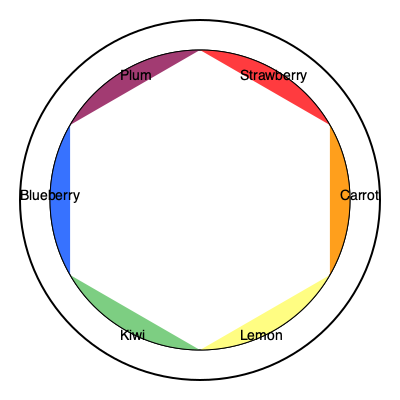Using the food-inspired color wheel provided, which two colors would create a complementary color scheme for a vibrant fabric design? To determine a complementary color scheme using the food-inspired color wheel, follow these steps:

1. Understand complementary colors: Complementary colors are pairs of colors that are opposite each other on the color wheel. They create high contrast and vibrant designs when used together.

2. Identify the color pairs: On this food-inspired color wheel, the complementary color pairs are:
   - Strawberry (red) and Kiwi (green)
   - Carrot (orange) and Blueberry (blue)
   - Lemon (yellow) and Plum (purple)

3. Choose a pair: Any of these pairs would create a complementary color scheme. For this example, let's select Carrot (orange) and Blueberry (blue).

4. Apply to fabric design: Using Carrot (orange) and Blueberry (blue) as complementary colors in a fabric design would create a vibrant and eye-catching pattern with high contrast.

5. Consider food-inspired patterns: Given the persona of a textile designer incorporating food-inspired patterns, you could create a design featuring carrots and blueberries or abstract patterns inspired by their shapes and textures.
Answer: Carrot (orange) and Blueberry (blue) 